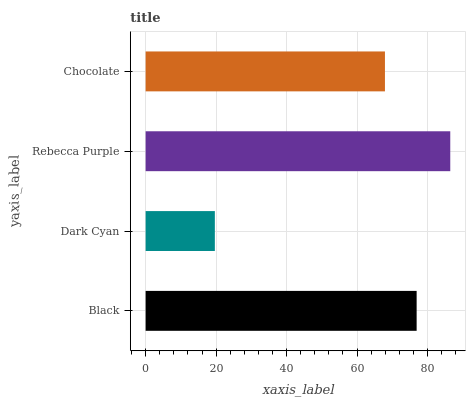Is Dark Cyan the minimum?
Answer yes or no. Yes. Is Rebecca Purple the maximum?
Answer yes or no. Yes. Is Rebecca Purple the minimum?
Answer yes or no. No. Is Dark Cyan the maximum?
Answer yes or no. No. Is Rebecca Purple greater than Dark Cyan?
Answer yes or no. Yes. Is Dark Cyan less than Rebecca Purple?
Answer yes or no. Yes. Is Dark Cyan greater than Rebecca Purple?
Answer yes or no. No. Is Rebecca Purple less than Dark Cyan?
Answer yes or no. No. Is Black the high median?
Answer yes or no. Yes. Is Chocolate the low median?
Answer yes or no. Yes. Is Rebecca Purple the high median?
Answer yes or no. No. Is Dark Cyan the low median?
Answer yes or no. No. 